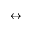Convert formula to latex. <formula><loc_0><loc_0><loc_500><loc_500>\leftrightarrow</formula> 